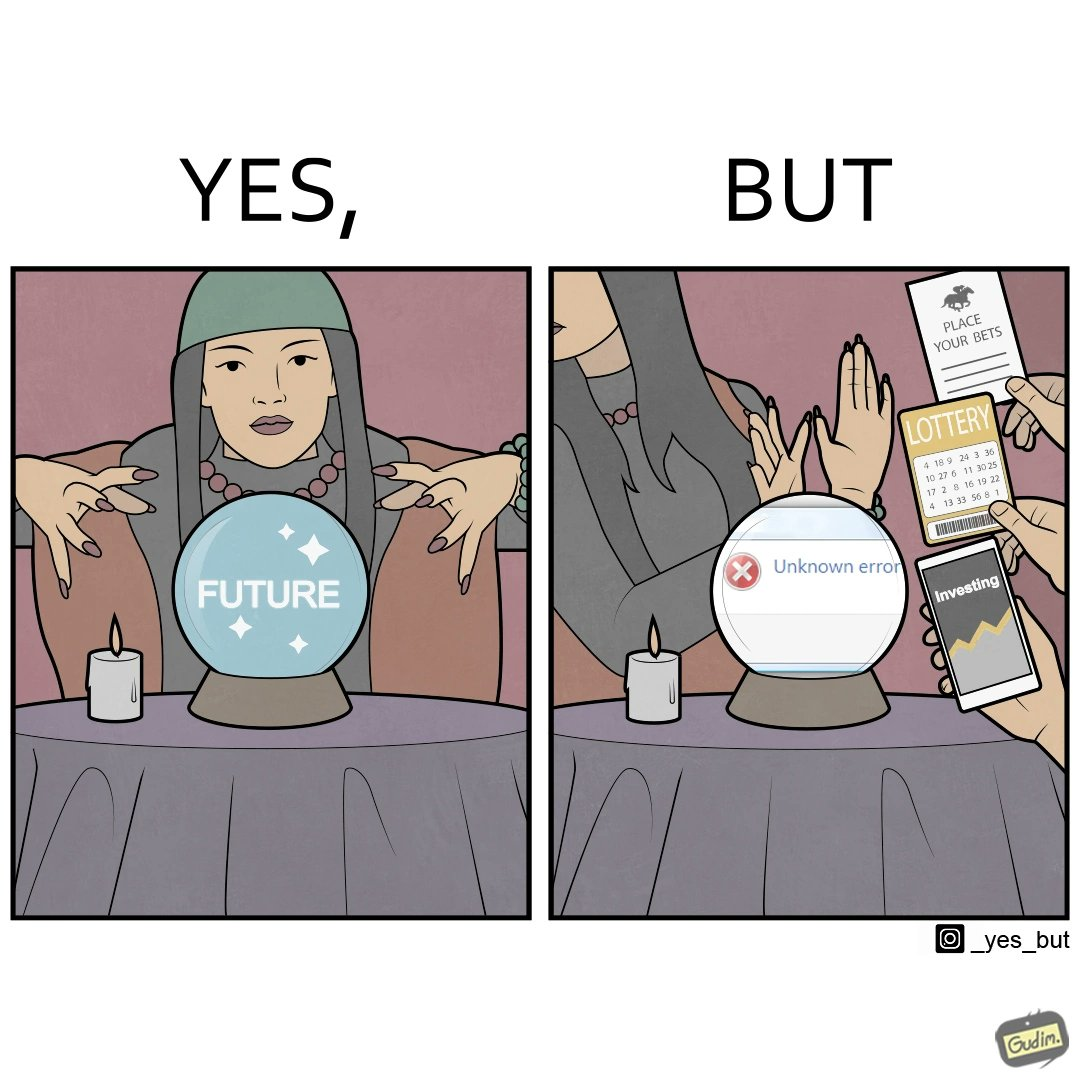Describe the content of this image. The people who claim to predict the future either find their predictions unsuccessful or avoid themselves from making claims related to finance, lotteries, and bets. 